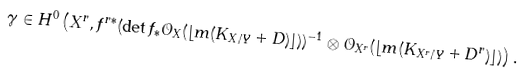<formula> <loc_0><loc_0><loc_500><loc_500>\gamma \in H ^ { 0 } \left ( X ^ { r } , f ^ { r * } ( \det f _ { * } \mathcal { O } _ { X } ( \lfloor m ( K _ { X / Y } + D ) \rfloor ) ) ^ { - 1 } \otimes \mathcal { O } _ { X ^ { r } } ( \lfloor m ( K _ { X ^ { r } / Y } + D ^ { r } ) \rfloor ) \right ) .</formula> 